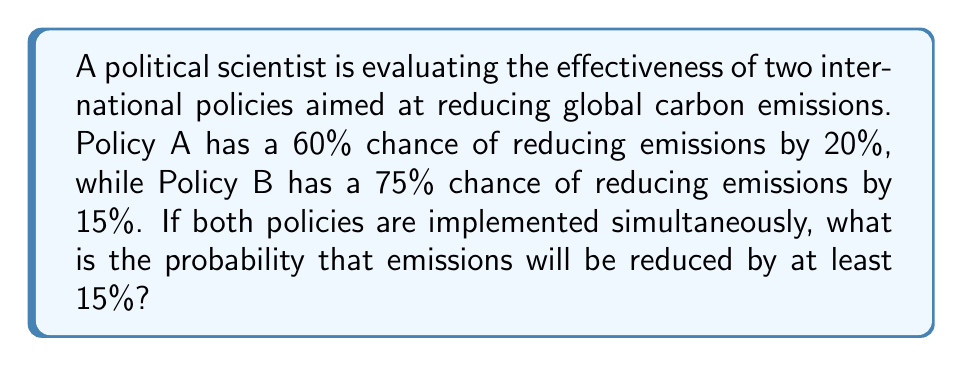Could you help me with this problem? To solve this problem, we need to use probability theory and decision analysis. Let's break it down step-by-step:

1. Define events:
   A: Policy A succeeds (60% chance)
   B: Policy B succeeds (75% chance)

2. We want to find the probability of emissions being reduced by at least 15%. This can happen in three ways:
   a) Only Policy A succeeds (20% reduction)
   b) Only Policy B succeeds (15% reduction)
   c) Both policies succeed (35% reduction)

3. Calculate the probabilities:
   P(A) = 0.60
   P(B) = 0.75
   P(not A) = 1 - P(A) = 0.40
   P(not B) = 1 - P(B) = 0.25

4. Calculate the probability of each scenario:
   a) P(A and not B) = P(A) * P(not B) = 0.60 * 0.25 = 0.15
   b) P(not A and B) = P(not A) * P(B) = 0.40 * 0.75 = 0.30
   c) P(A and B) = P(A) * P(B) = 0.60 * 0.75 = 0.45

5. Sum the probabilities of all favorable outcomes:
   P(at least 15% reduction) = P(A and not B) + P(not A and B) + P(A and B)

6. Plug in the values:
   P(at least 15% reduction) = 0.15 + 0.30 + 0.45 = 0.90

Therefore, the probability that emissions will be reduced by at least 15% is 0.90 or 90%.
Answer: The probability that emissions will be reduced by at least 15% if both policies are implemented simultaneously is 0.90 or 90%. 